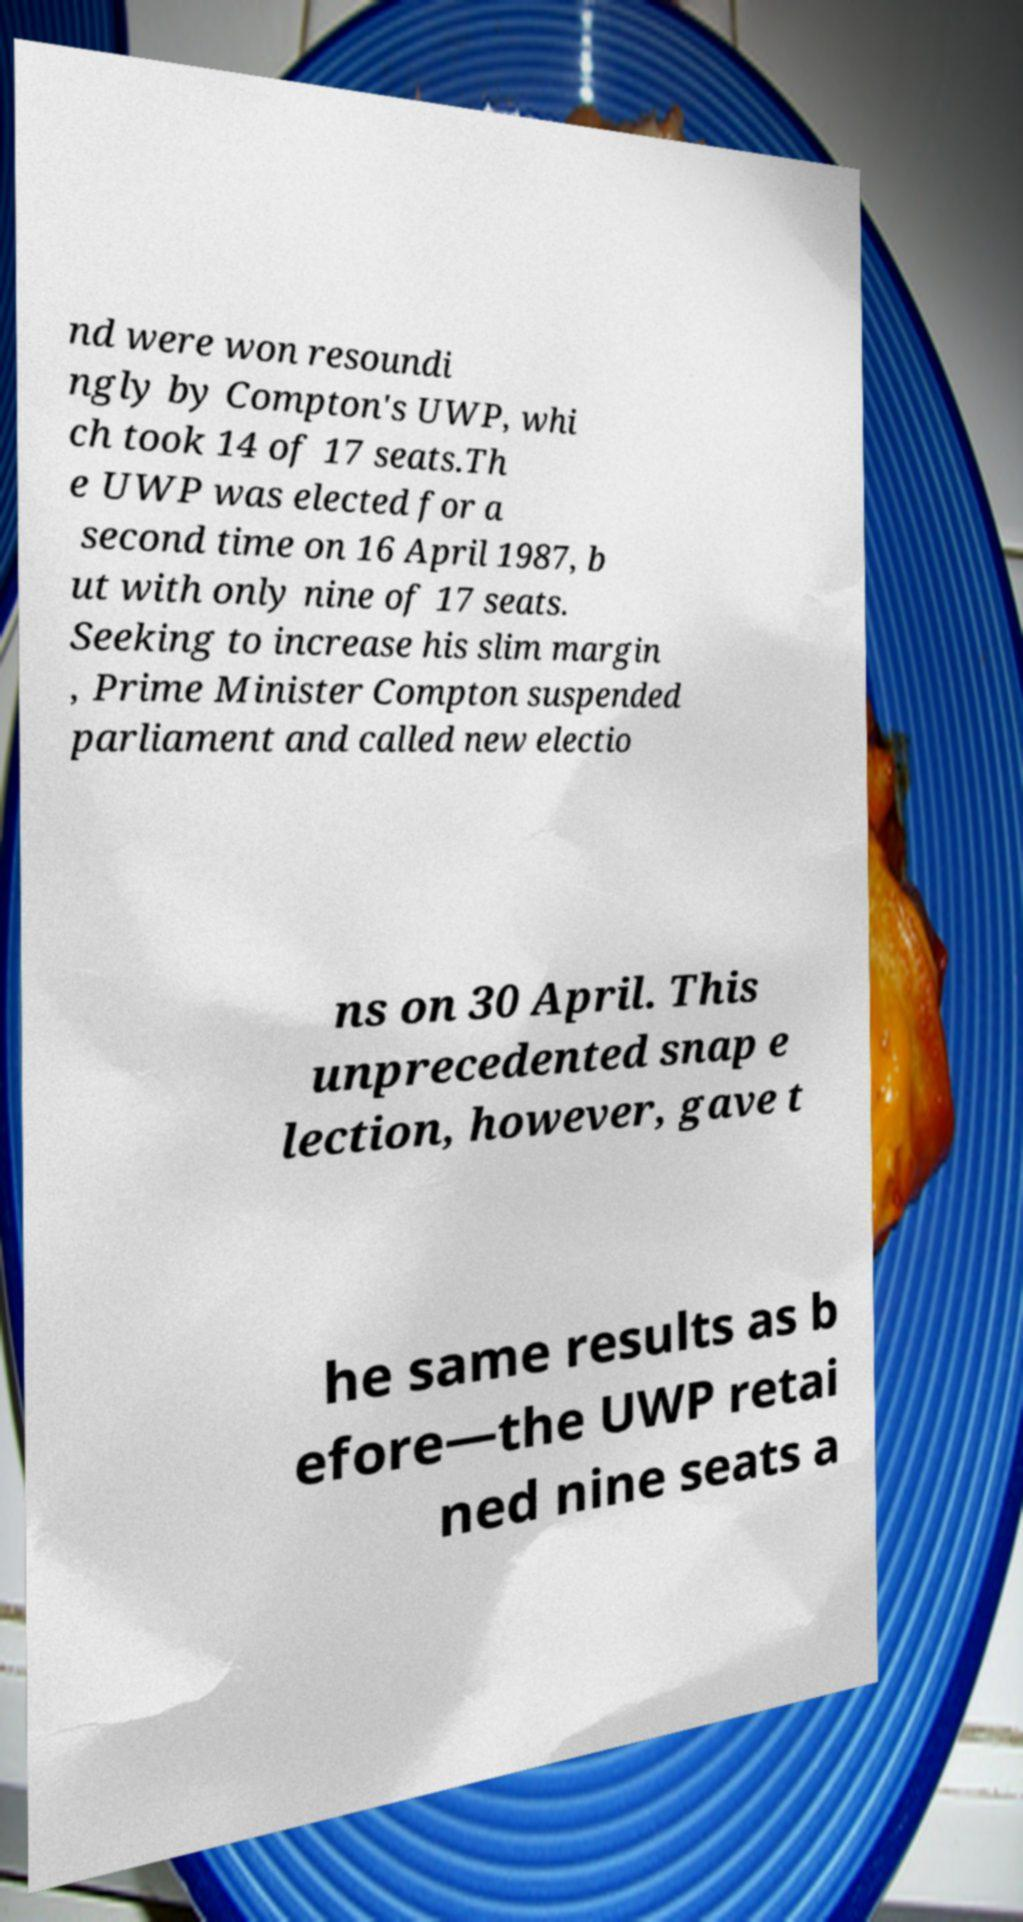Can you read and provide the text displayed in the image?This photo seems to have some interesting text. Can you extract and type it out for me? nd were won resoundi ngly by Compton's UWP, whi ch took 14 of 17 seats.Th e UWP was elected for a second time on 16 April 1987, b ut with only nine of 17 seats. Seeking to increase his slim margin , Prime Minister Compton suspended parliament and called new electio ns on 30 April. This unprecedented snap e lection, however, gave t he same results as b efore—the UWP retai ned nine seats a 